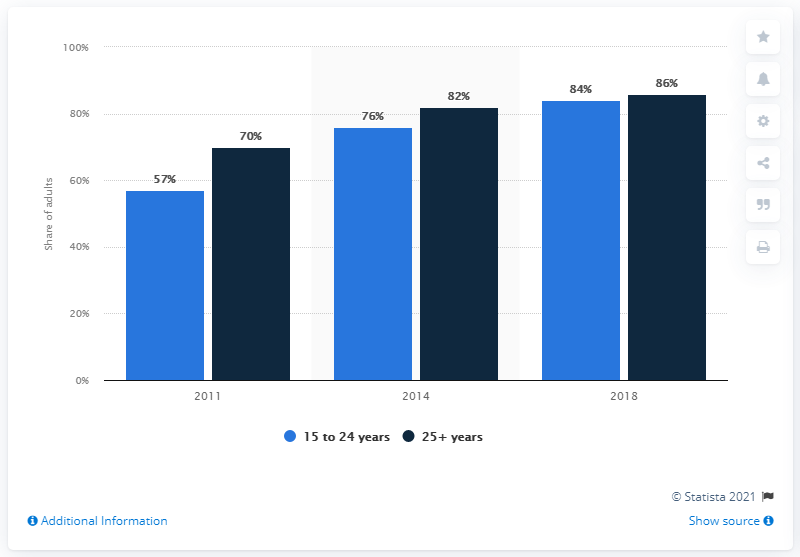Give some essential details in this illustration. In 2018, the age group with the highest share of accounts was individuals aged 25 years and above. In which year was the difference between the two age categories the greatest? 